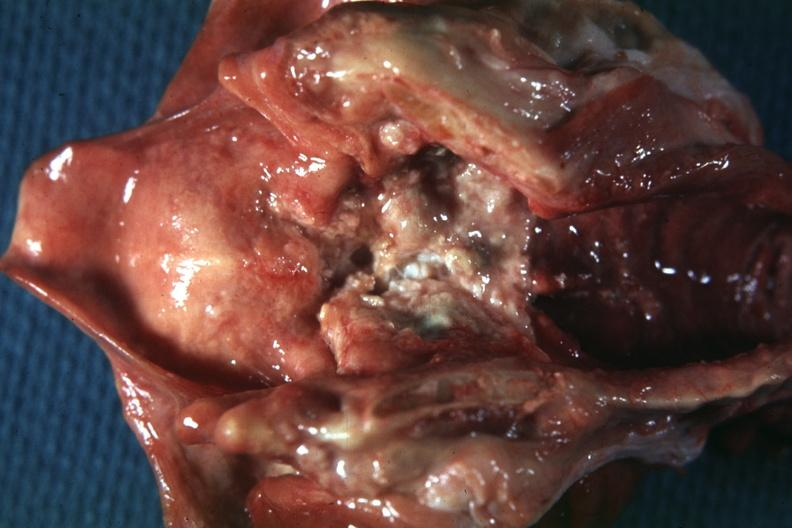does this image show excellent very large ulcerative lesion?
Answer the question using a single word or phrase. Yes 